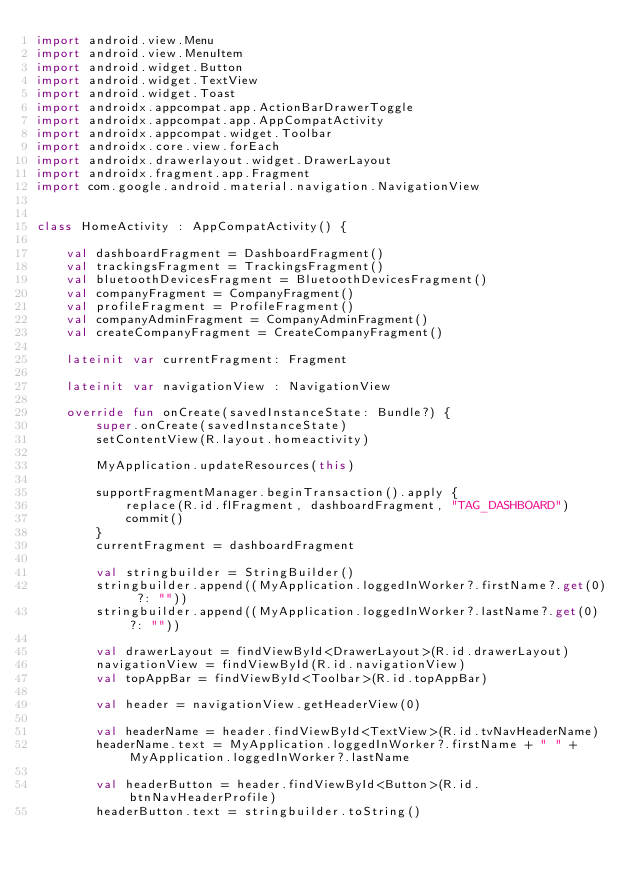<code> <loc_0><loc_0><loc_500><loc_500><_Kotlin_>import android.view.Menu
import android.view.MenuItem
import android.widget.Button
import android.widget.TextView
import android.widget.Toast
import androidx.appcompat.app.ActionBarDrawerToggle
import androidx.appcompat.app.AppCompatActivity
import androidx.appcompat.widget.Toolbar
import androidx.core.view.forEach
import androidx.drawerlayout.widget.DrawerLayout
import androidx.fragment.app.Fragment
import com.google.android.material.navigation.NavigationView


class HomeActivity : AppCompatActivity() {

    val dashboardFragment = DashboardFragment()
    val trackingsFragment = TrackingsFragment()
    val bluetoothDevicesFragment = BluetoothDevicesFragment()
    val companyFragment = CompanyFragment()
    val profileFragment = ProfileFragment()
    val companyAdminFragment = CompanyAdminFragment()
    val createCompanyFragment = CreateCompanyFragment()

    lateinit var currentFragment: Fragment

    lateinit var navigationView : NavigationView

    override fun onCreate(savedInstanceState: Bundle?) {
        super.onCreate(savedInstanceState)
        setContentView(R.layout.homeactivity)

        MyApplication.updateResources(this)

        supportFragmentManager.beginTransaction().apply {
            replace(R.id.flFragment, dashboardFragment, "TAG_DASHBOARD")
            commit()
        }
        currentFragment = dashboardFragment

        val stringbuilder = StringBuilder()
        stringbuilder.append((MyApplication.loggedInWorker?.firstName?.get(0) ?: ""))
        stringbuilder.append((MyApplication.loggedInWorker?.lastName?.get(0) ?: ""))

        val drawerLayout = findViewById<DrawerLayout>(R.id.drawerLayout)
        navigationView = findViewById(R.id.navigationView)
        val topAppBar = findViewById<Toolbar>(R.id.topAppBar)

        val header = navigationView.getHeaderView(0)

        val headerName = header.findViewById<TextView>(R.id.tvNavHeaderName)
        headerName.text = MyApplication.loggedInWorker?.firstName + " " + MyApplication.loggedInWorker?.lastName

        val headerButton = header.findViewById<Button>(R.id.btnNavHeaderProfile)
        headerButton.text = stringbuilder.toString()</code> 